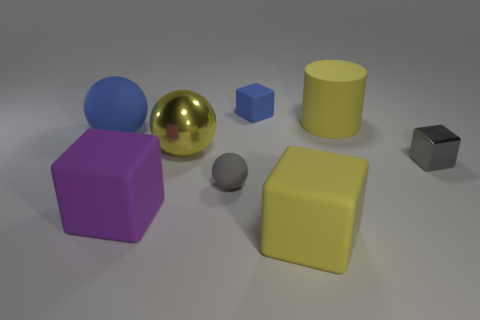Add 2 rubber balls. How many objects exist? 10 Subtract all cylinders. How many objects are left? 7 Add 1 large red rubber things. How many large red rubber things exist? 1 Subtract 0 brown cylinders. How many objects are left? 8 Subtract all blue matte blocks. Subtract all tiny shiny things. How many objects are left? 6 Add 2 yellow balls. How many yellow balls are left? 3 